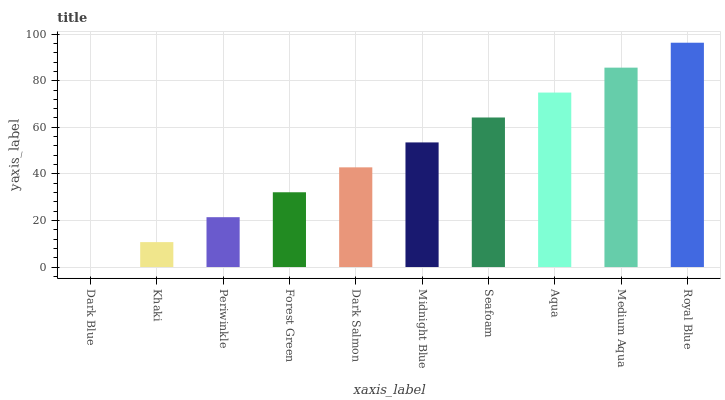Is Dark Blue the minimum?
Answer yes or no. Yes. Is Royal Blue the maximum?
Answer yes or no. Yes. Is Khaki the minimum?
Answer yes or no. No. Is Khaki the maximum?
Answer yes or no. No. Is Khaki greater than Dark Blue?
Answer yes or no. Yes. Is Dark Blue less than Khaki?
Answer yes or no. Yes. Is Dark Blue greater than Khaki?
Answer yes or no. No. Is Khaki less than Dark Blue?
Answer yes or no. No. Is Midnight Blue the high median?
Answer yes or no. Yes. Is Dark Salmon the low median?
Answer yes or no. Yes. Is Seafoam the high median?
Answer yes or no. No. Is Royal Blue the low median?
Answer yes or no. No. 